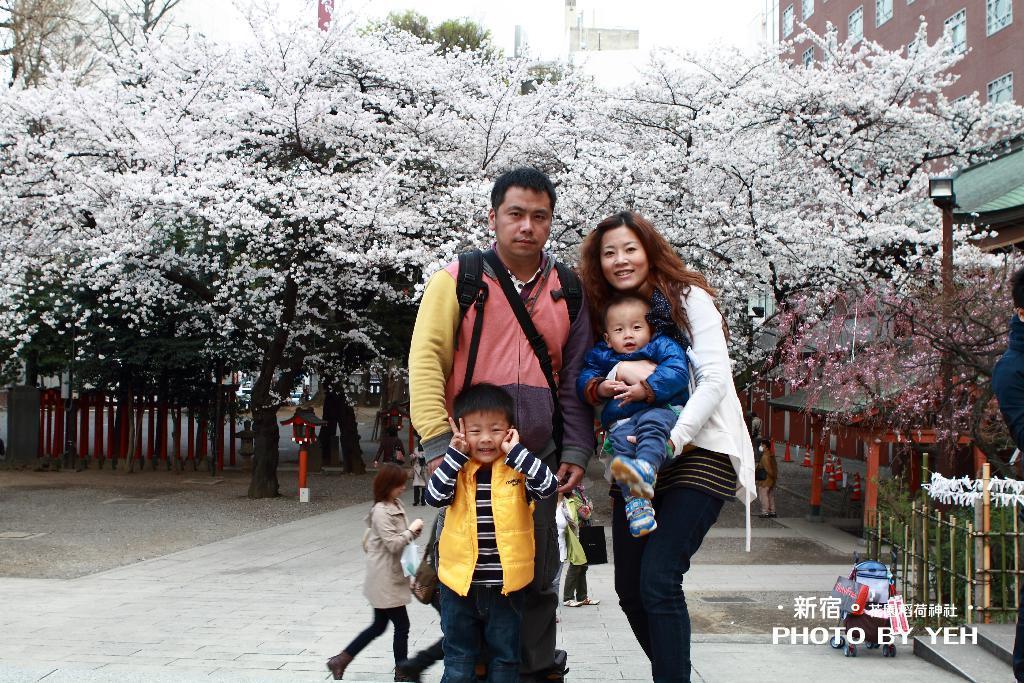Please provide a concise description of this image. In this picture we can see a man, child and a woman holding a baby in her hands. There is some text, a fence around plants and a person is visible on the right side. We can see a few traffic cones, shed and a few people at the back. We can see some objects , poles, trees and buildings in the background. 